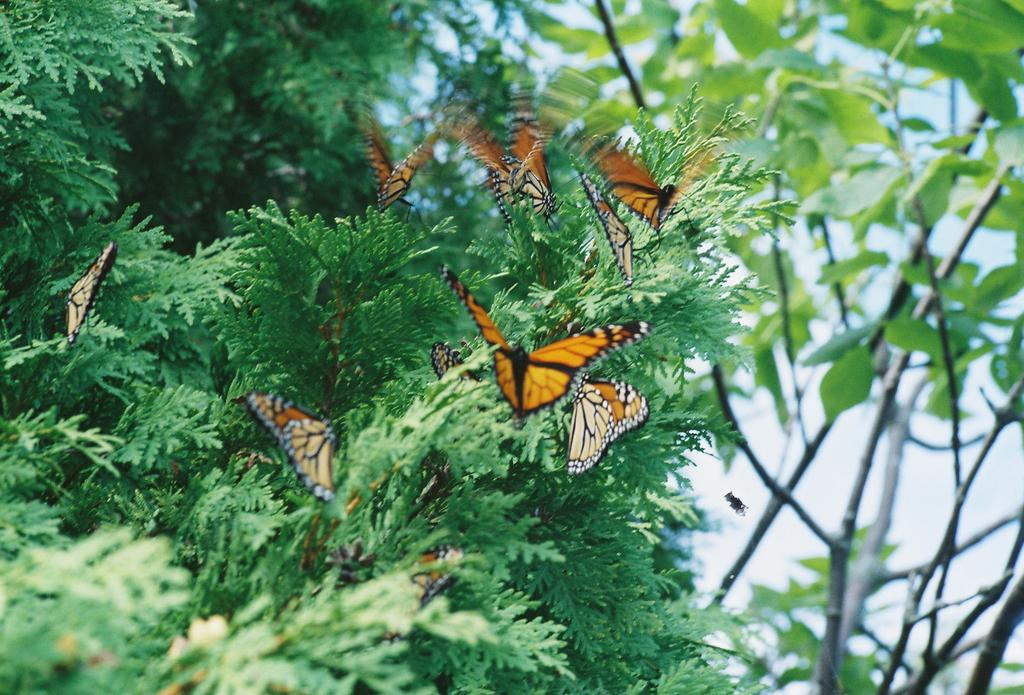What is the primary subject of the image? The primary subject of the image is the many plants. Are there any living creatures visible in the image? Yes, there is an insect and butterflies in the image. What is the insect doing in the image? The facts provided do not specify the insect's actions. What can be seen in the background of the image? There is a sky visible in the image. What type of silver vein can be seen running through the plants in the image? There is no mention of silver veins in the image; the plants are not described as having any metallic features. 